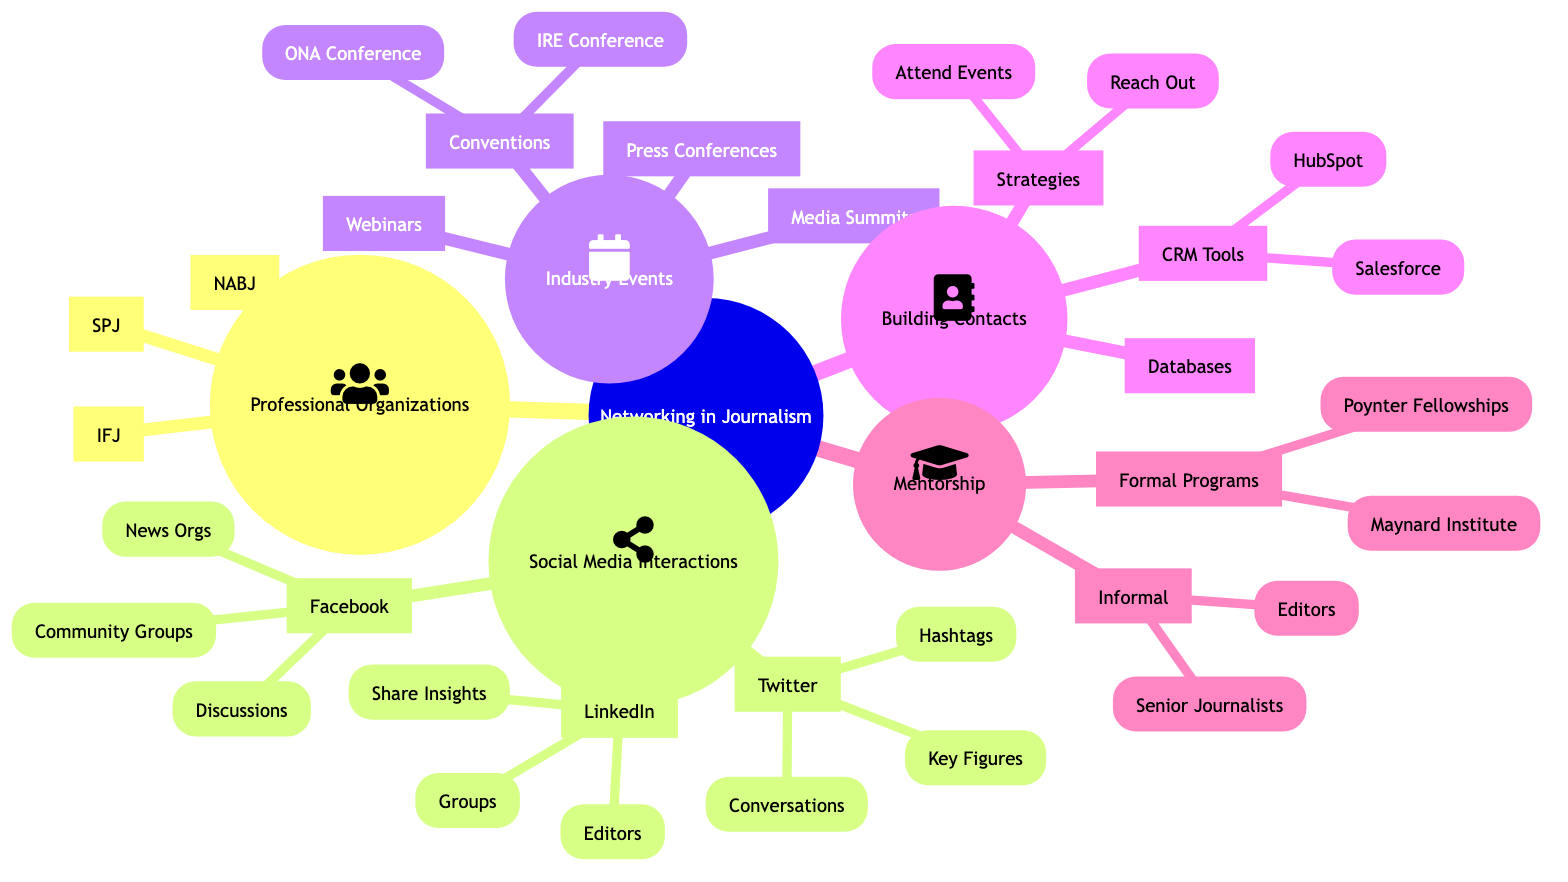What are three professional organizations listed? The diagram lists three professional organizations under the main node "Professional Organizations". They are the Society of Professional Journalists (SPJ), International Federation of Journalists (IFJ), and National Association of Black Journalists (NABJ).
Answer: SPJ, IFJ, NABJ How many platforms are mentioned under Social Media Interactions? The diagram shows three social media platforms: Twitter, LinkedIn, and Facebook. This information can be found directly beneath the "Social Media Interactions" node.
Answer: 3 What is a strategy for building contacts? Among the options under "Networking Strategies", one is to "Attend Events," which is a suggested approach to building and maintaining contacts. This strategy is one of the listed tactics in the "Building and Maintaining Contacts" section.
Answer: Attend Events Which events are specifically categorized under Industry Events? The section "Industry Events" includes Press Conferences, Journalism Conventions, Webinars and Online Workshops, and Media Summits. Under Journalism Conventions, two specific conferences are also noted: ONA Annual Conference and Investigative Reporters and Editors Conference (IRE).
Answer: Press Conferences, Journalism Conventions, Webinars and Online Workshops, Media Summits, ONA Annual Conference, IRE Conference What is one example of a formal mentorship program? In the section on "Formal Mentorship Programs," the diagram lists the Maynard Institute and Poynter Fellowships. Both of these are considered formal mentorship opportunities for journalists.
Answer: Maynard Institute What social media platform encourages real-time discussions? Among the listed interactions under Facebook in the Social Media Interactions section, "Real-time Discussions" is specified as one of the ways journalists interact on that platform.
Answer: Facebook Which tool is mentioned for managing contacts? "Salesforce" and "HubSpot" are both mentioned under the "Using a CRM Tool" node within the "Building and Maintaining Contacts" category, highlighting tools recommended for managing contacts.
Answer: Salesforce, HubSpot How many specific hashtags are listed under Twitter? The diagram indicates one specific category of hashtags, listed as "Journalist Hashtags (#journchat, #medialiteracy)," indicating that this is a group of hashtags.
Answer: 1 